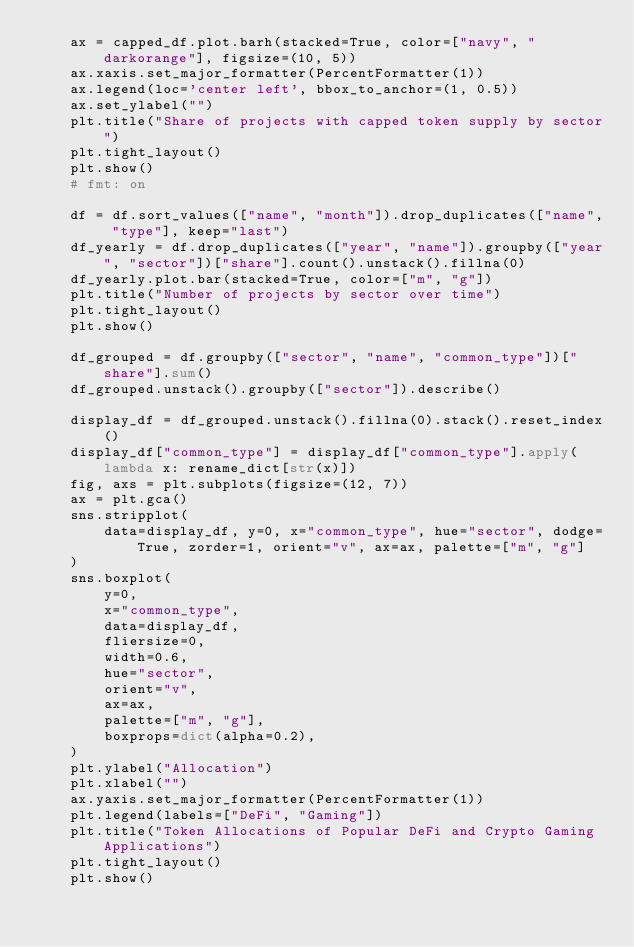<code> <loc_0><loc_0><loc_500><loc_500><_Python_>    ax = capped_df.plot.barh(stacked=True, color=["navy", "darkorange"], figsize=(10, 5))
    ax.xaxis.set_major_formatter(PercentFormatter(1))
    ax.legend(loc='center left', bbox_to_anchor=(1, 0.5))
    ax.set_ylabel("")
    plt.title("Share of projects with capped token supply by sector")
    plt.tight_layout()
    plt.show()
    # fmt: on

    df = df.sort_values(["name", "month"]).drop_duplicates(["name", "type"], keep="last")
    df_yearly = df.drop_duplicates(["year", "name"]).groupby(["year", "sector"])["share"].count().unstack().fillna(0)
    df_yearly.plot.bar(stacked=True, color=["m", "g"])
    plt.title("Number of projects by sector over time")
    plt.tight_layout()
    plt.show()

    df_grouped = df.groupby(["sector", "name", "common_type"])["share"].sum()
    df_grouped.unstack().groupby(["sector"]).describe()

    display_df = df_grouped.unstack().fillna(0).stack().reset_index()
    display_df["common_type"] = display_df["common_type"].apply(lambda x: rename_dict[str(x)])
    fig, axs = plt.subplots(figsize=(12, 7))
    ax = plt.gca()
    sns.stripplot(
        data=display_df, y=0, x="common_type", hue="sector", dodge=True, zorder=1, orient="v", ax=ax, palette=["m", "g"]
    )
    sns.boxplot(
        y=0,
        x="common_type",
        data=display_df,
        fliersize=0,
        width=0.6,
        hue="sector",
        orient="v",
        ax=ax,
        palette=["m", "g"],
        boxprops=dict(alpha=0.2),
    )
    plt.ylabel("Allocation")
    plt.xlabel("")
    ax.yaxis.set_major_formatter(PercentFormatter(1))
    plt.legend(labels=["DeFi", "Gaming"])
    plt.title("Token Allocations of Popular DeFi and Crypto Gaming Applications")
    plt.tight_layout()
    plt.show()
</code> 